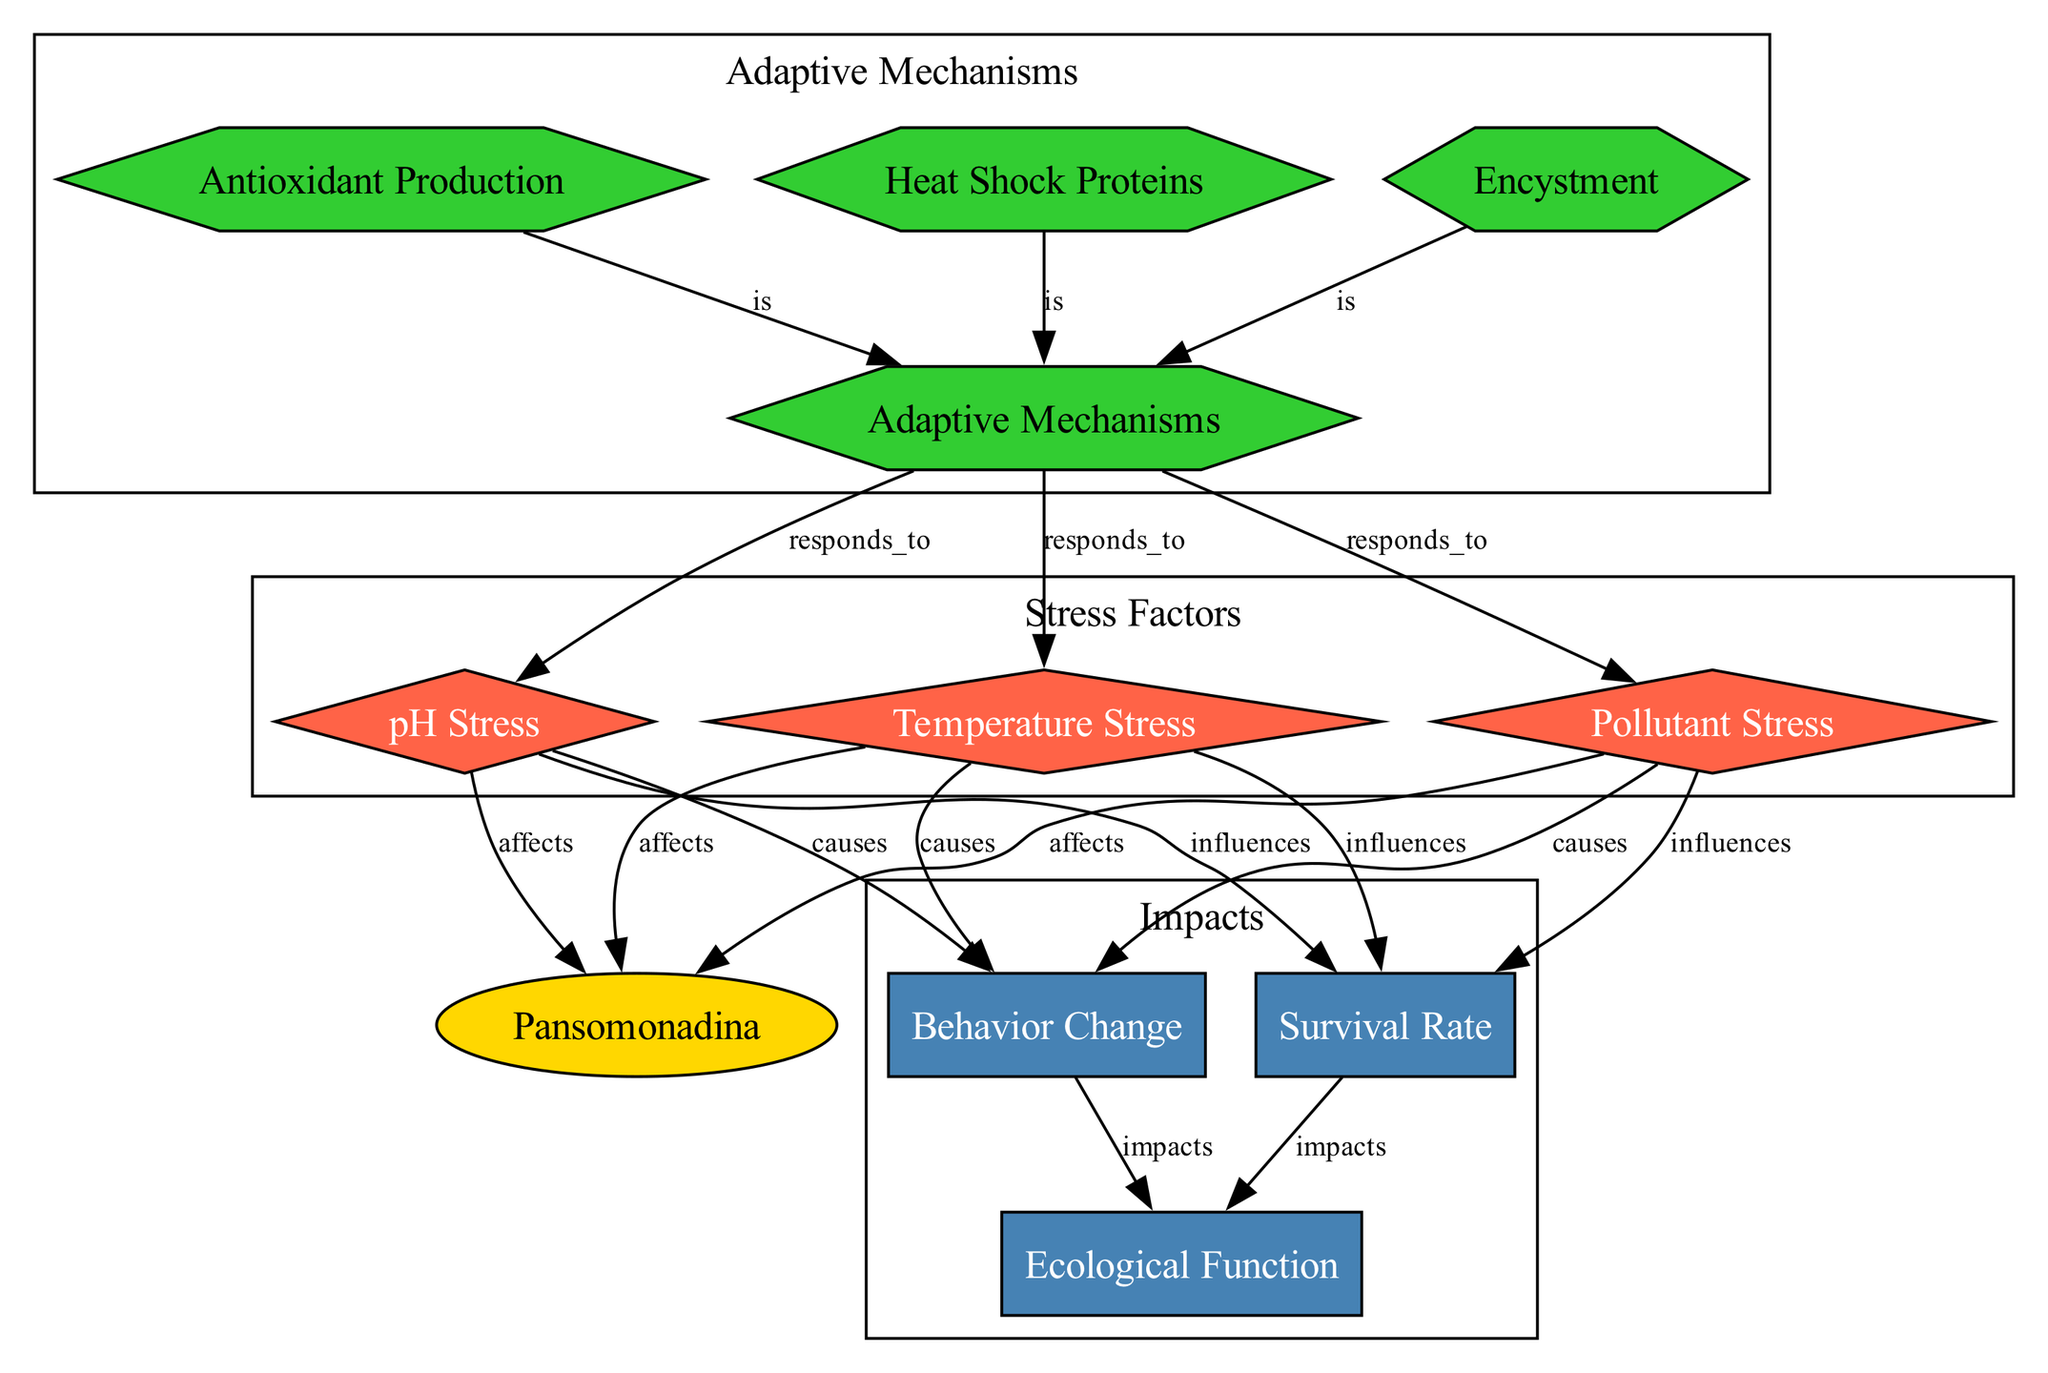What is the main entity discussed in the diagram? The main entity is represented in the diagram and is labeled as "Pansomonadina," indicating that the focus is on these single-celled protists.
Answer: Pansomonadina How many stress factors are depicted in the diagram? The diagram lists three distinct stress factors: pH Stress, Temperature Stress, and Pollutant Stress, which can be counted directly from the nodes labeled as such.
Answer: 3 What type of shape represents adaptive mechanisms in the diagram? Adaptive mechanisms are represented by hexagons, as indicated by the styling dedicated to nodes of that type in the diagram.
Answer: Hexagon Which stress factor impacts the survival rate? The surviving rate is influenced by pH Stress, Temperature Stress, and Pollutant Stress, which directly influence this factor as shown by the arrows linking these stress factors to Survival Rate.
Answer: pH Stress, Temperature Stress, Pollutant Stress What adaptive mechanism is generated to reduce oxidative stress? The diagram indicates that "Antioxidant Production" is listed as a specific adaptive mechanism aimed at coping with oxidative stress, which can be read directly from the node labeled as such.
Answer: Antioxidant Production How does behavior change impact ecological function? Behavior change impacts ecological function directly, as represented by an arrow from the "Behavior Change" node to the "Ecological Function" node, indicating this direct influence in a cause-effect manner.
Answer: Impacts What do heat shock proteins assist with? Heat shock proteins are identified in the diagram as proteins that aid in refolding damaged proteins, which is mentioned directly in the description provided for the node.
Answer: Refolding damaged proteins Which adaptive mechanism forms cysts to survive unfavorable conditions? The node labeled "Encystment" specifies that this mechanism involves forming cysts, and provides a direct answer to the role it plays in overcoming environmental stressors.
Answer: Encystment What is the relationship between pollutant stress and behavior change? Pollutant stress causes behavior change, as indicated by the labeled directed edge that connects the "Pollutant Stress" node to the "Behavior Change" node, showing this cause-and-effect relationship.
Answer: Causes 